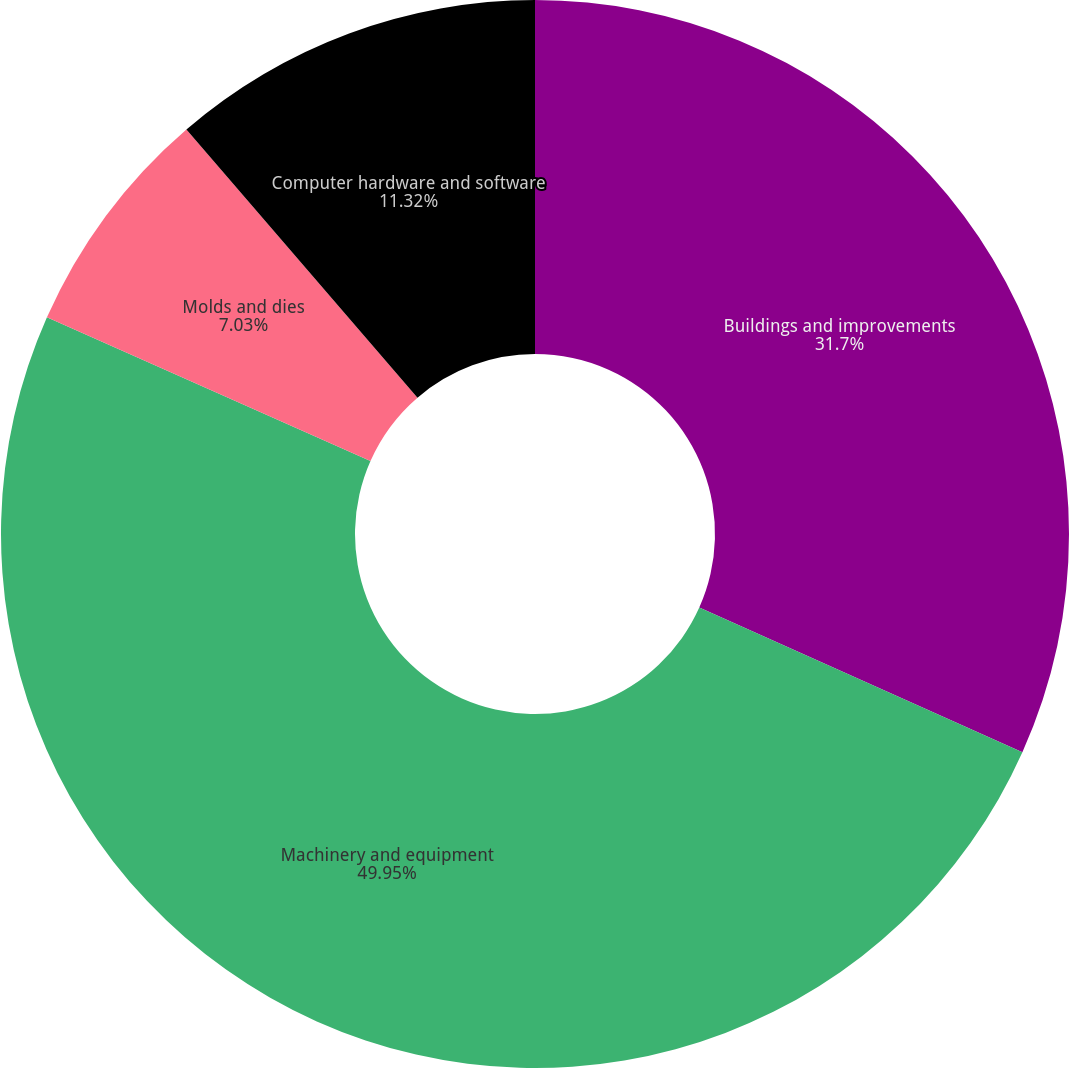<chart> <loc_0><loc_0><loc_500><loc_500><pie_chart><fcel>Buildings and improvements<fcel>Machinery and equipment<fcel>Molds and dies<fcel>Computer hardware and software<nl><fcel>31.7%<fcel>49.95%<fcel>7.03%<fcel>11.32%<nl></chart> 